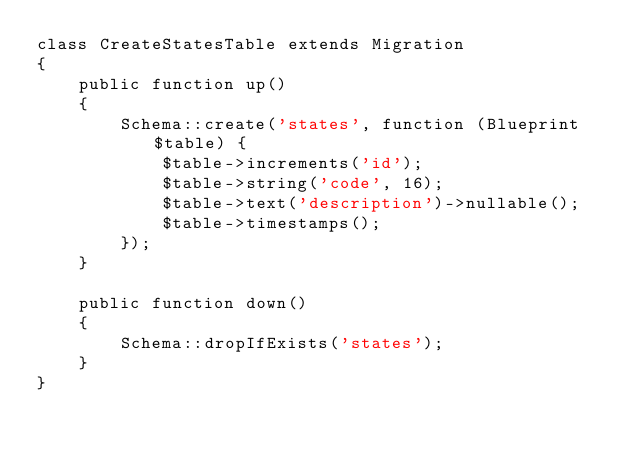<code> <loc_0><loc_0><loc_500><loc_500><_PHP_>class CreateStatesTable extends Migration
{
    public function up()
    {
        Schema::create('states', function (Blueprint $table) {
            $table->increments('id');
            $table->string('code', 16);
            $table->text('description')->nullable();
            $table->timestamps();
        });
    }

    public function down()
    {
        Schema::dropIfExists('states');
    }
}
</code> 